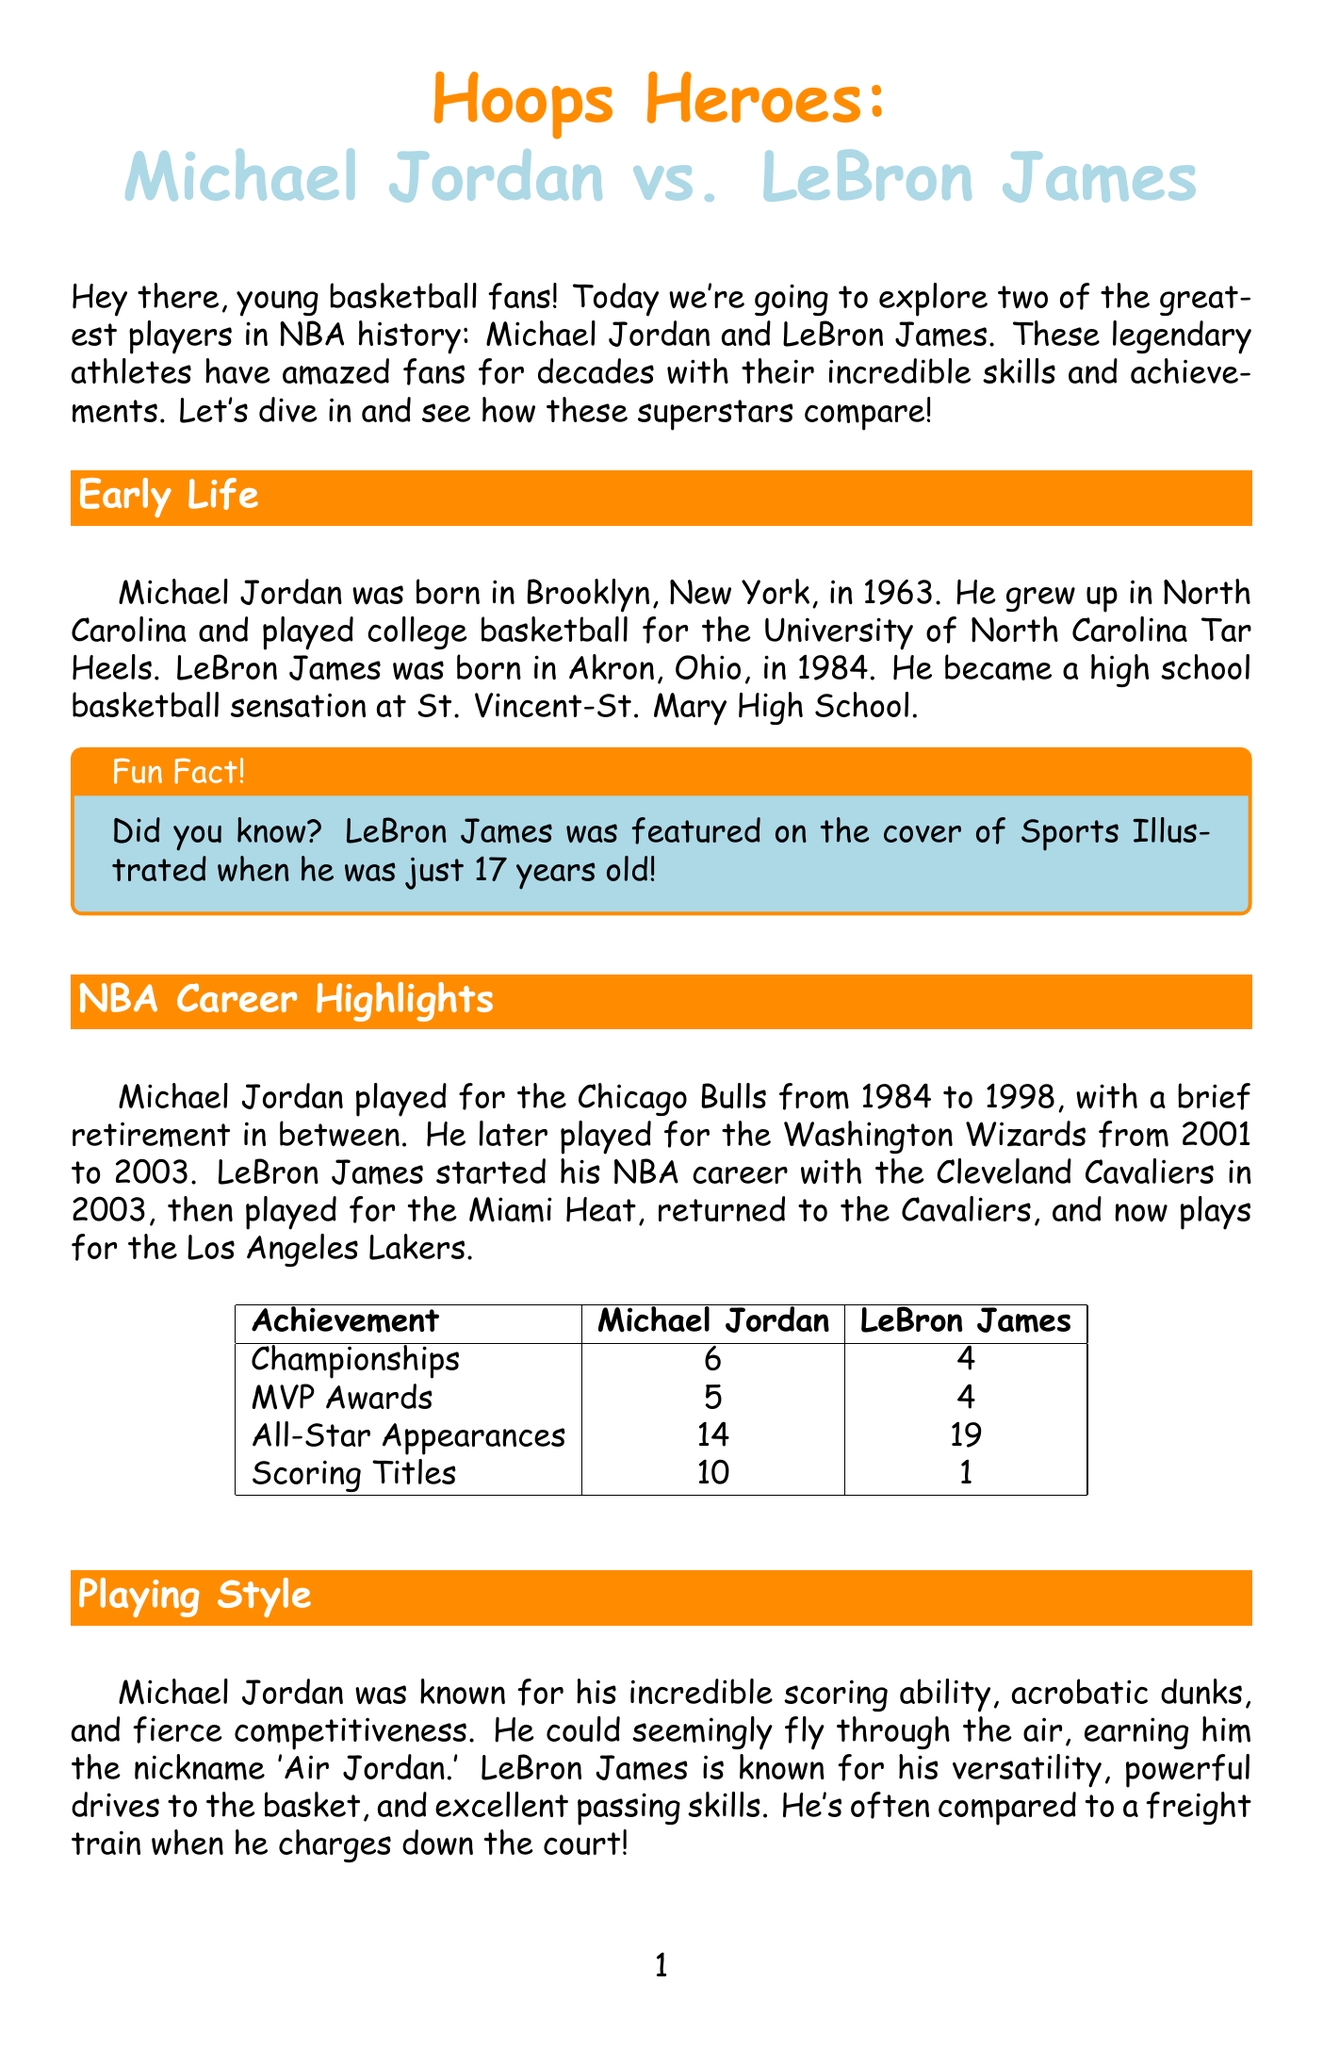What year was Michael Jordan born? Michael Jordan was born in Brooklyn, New York, in 1963, as mentioned in the Early Life section.
Answer: 1963 How many championship titles does LeBron James have? The Career Achievements infographic states that LeBron James has won 4 championships.
Answer: 4 What nickname is Michael Jordan known by? The Playing Style section refers to Michael Jordan as 'Air Jordan,' which highlights his unique status.
Answer: Air Jordan How many All-Star appearances does Michael Jordan have? In the Career Achievements infographic, it shows that Michael Jordan made 14 All-Star appearances.
Answer: 14 Which player played for the Miami Heat? The NBA Career Highlights section indicates that LeBron James played for the Miami Heat during his career.
Answer: LeBron James What is an interesting fact about LeBron James at 17? The Early Life section describes that LeBron James was featured on the cover of Sports Illustrated when he was just 17 years old.
Answer: Featured on Sports Illustrated What type of school did LeBron James open? The Impact Beyond Basketball section discusses the I Promise School that LeBron James opened for at-risk kids.
Answer: I Promise School How many MVP awards does Michael Jordan have? The Career Achievements infographic lists that Michael Jordan has won 5 MVP awards.
Answer: 5 What was the title of the movie Michael Jordan starred in? The Cool Fact box mentions that Michael Jordan starred in 'Space Jam' (1996).
Answer: Space Jam 